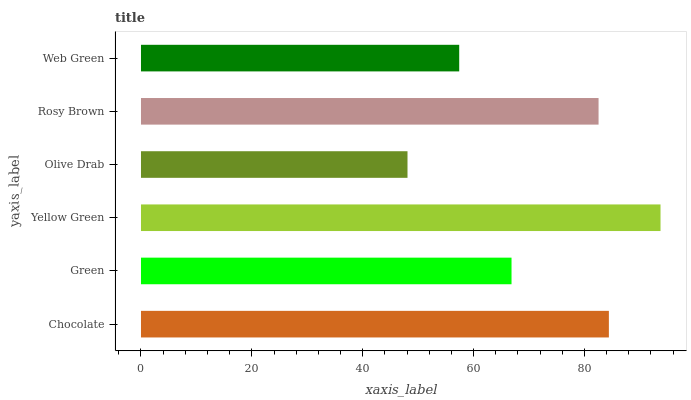Is Olive Drab the minimum?
Answer yes or no. Yes. Is Yellow Green the maximum?
Answer yes or no. Yes. Is Green the minimum?
Answer yes or no. No. Is Green the maximum?
Answer yes or no. No. Is Chocolate greater than Green?
Answer yes or no. Yes. Is Green less than Chocolate?
Answer yes or no. Yes. Is Green greater than Chocolate?
Answer yes or no. No. Is Chocolate less than Green?
Answer yes or no. No. Is Rosy Brown the high median?
Answer yes or no. Yes. Is Green the low median?
Answer yes or no. Yes. Is Yellow Green the high median?
Answer yes or no. No. Is Olive Drab the low median?
Answer yes or no. No. 